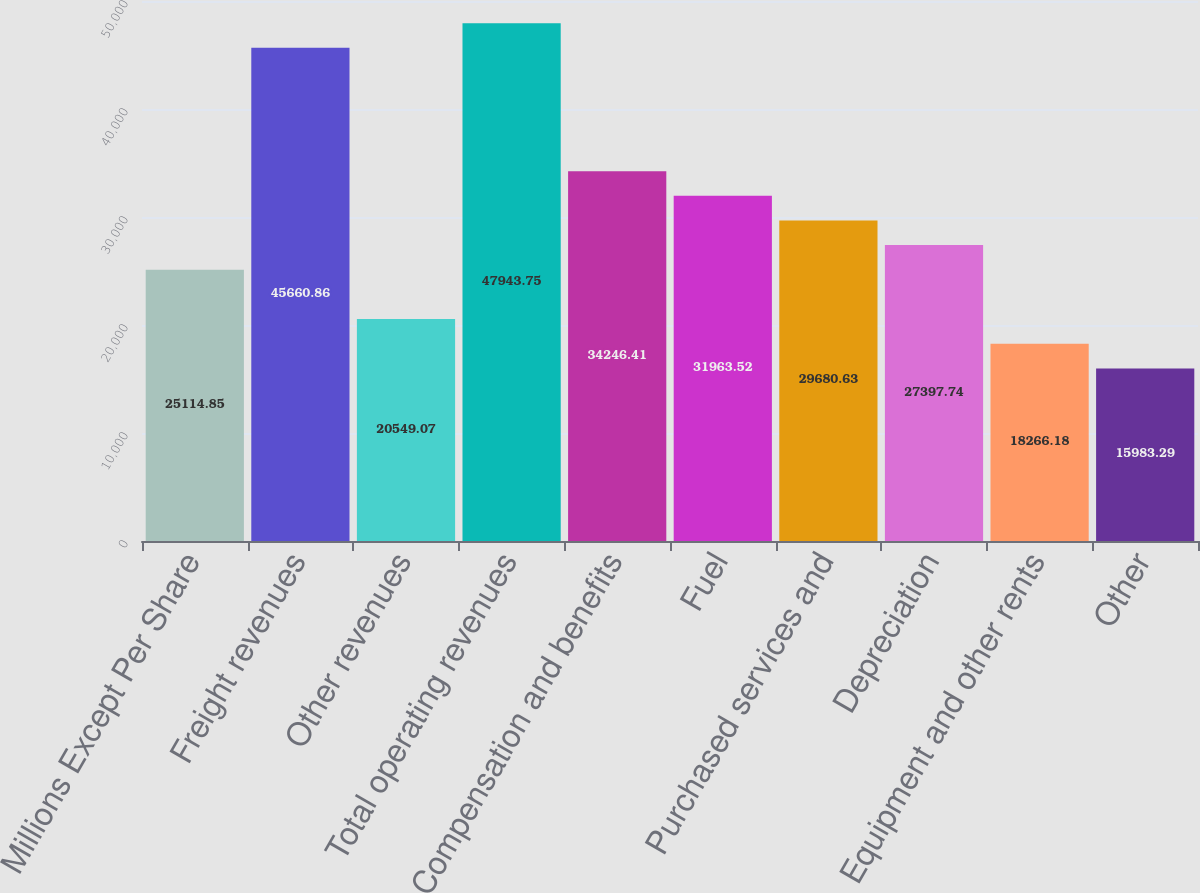<chart> <loc_0><loc_0><loc_500><loc_500><bar_chart><fcel>Millions Except Per Share<fcel>Freight revenues<fcel>Other revenues<fcel>Total operating revenues<fcel>Compensation and benefits<fcel>Fuel<fcel>Purchased services and<fcel>Depreciation<fcel>Equipment and other rents<fcel>Other<nl><fcel>25114.8<fcel>45660.9<fcel>20549.1<fcel>47943.8<fcel>34246.4<fcel>31963.5<fcel>29680.6<fcel>27397.7<fcel>18266.2<fcel>15983.3<nl></chart> 